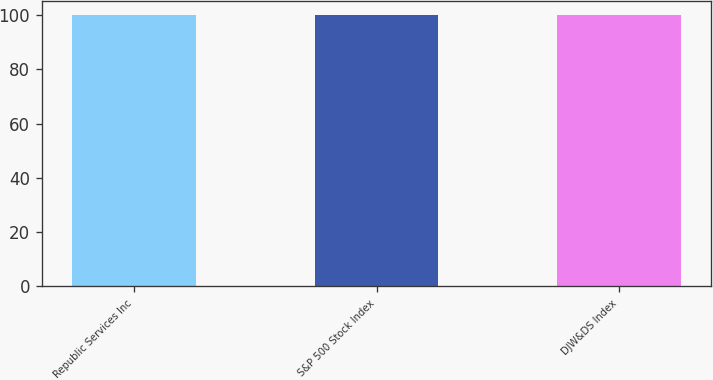<chart> <loc_0><loc_0><loc_500><loc_500><bar_chart><fcel>Republic Services Inc<fcel>S&P 500 Stock Index<fcel>DJW&DS Index<nl><fcel>100<fcel>100.1<fcel>100.2<nl></chart> 